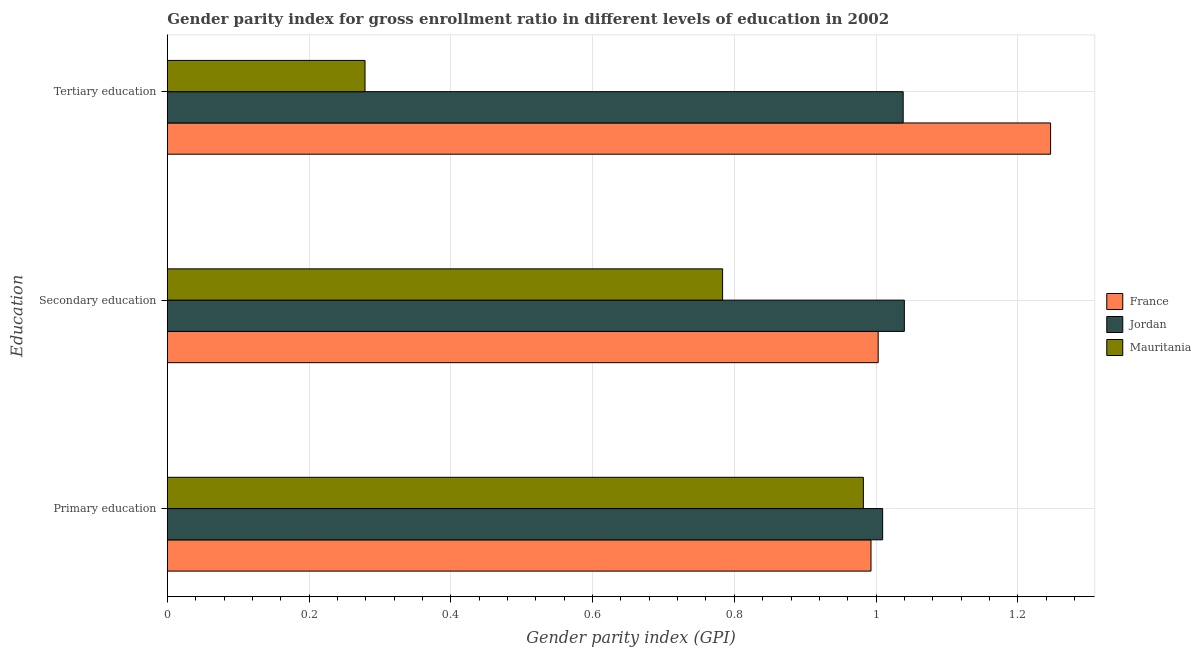How many different coloured bars are there?
Your answer should be very brief. 3. Are the number of bars per tick equal to the number of legend labels?
Your answer should be very brief. Yes. Are the number of bars on each tick of the Y-axis equal?
Provide a short and direct response. Yes. How many bars are there on the 2nd tick from the top?
Your answer should be very brief. 3. What is the gender parity index in tertiary education in Jordan?
Provide a succinct answer. 1.04. Across all countries, what is the maximum gender parity index in secondary education?
Your answer should be very brief. 1.04. Across all countries, what is the minimum gender parity index in secondary education?
Your answer should be very brief. 0.78. In which country was the gender parity index in secondary education maximum?
Your response must be concise. Jordan. In which country was the gender parity index in tertiary education minimum?
Make the answer very short. Mauritania. What is the total gender parity index in tertiary education in the graph?
Your response must be concise. 2.56. What is the difference between the gender parity index in primary education in France and that in Jordan?
Give a very brief answer. -0.02. What is the difference between the gender parity index in primary education in France and the gender parity index in secondary education in Mauritania?
Your response must be concise. 0.21. What is the average gender parity index in primary education per country?
Your answer should be very brief. 0.99. What is the difference between the gender parity index in tertiary education and gender parity index in secondary education in France?
Your answer should be compact. 0.24. In how many countries, is the gender parity index in tertiary education greater than 0.32 ?
Give a very brief answer. 2. What is the ratio of the gender parity index in secondary education in France to that in Mauritania?
Make the answer very short. 1.28. Is the difference between the gender parity index in primary education in France and Jordan greater than the difference between the gender parity index in tertiary education in France and Jordan?
Your response must be concise. No. What is the difference between the highest and the second highest gender parity index in tertiary education?
Your answer should be very brief. 0.21. What is the difference between the highest and the lowest gender parity index in tertiary education?
Your response must be concise. 0.97. Is the sum of the gender parity index in primary education in France and Jordan greater than the maximum gender parity index in tertiary education across all countries?
Provide a succinct answer. Yes. What does the 3rd bar from the bottom in Tertiary education represents?
Your response must be concise. Mauritania. Are all the bars in the graph horizontal?
Keep it short and to the point. Yes. What is the difference between two consecutive major ticks on the X-axis?
Provide a succinct answer. 0.2. How are the legend labels stacked?
Offer a very short reply. Vertical. What is the title of the graph?
Your answer should be compact. Gender parity index for gross enrollment ratio in different levels of education in 2002. Does "Sao Tome and Principe" appear as one of the legend labels in the graph?
Give a very brief answer. No. What is the label or title of the X-axis?
Give a very brief answer. Gender parity index (GPI). What is the label or title of the Y-axis?
Your response must be concise. Education. What is the Gender parity index (GPI) in France in Primary education?
Provide a succinct answer. 0.99. What is the Gender parity index (GPI) in Jordan in Primary education?
Your answer should be very brief. 1.01. What is the Gender parity index (GPI) of Mauritania in Primary education?
Your response must be concise. 0.98. What is the Gender parity index (GPI) in France in Secondary education?
Keep it short and to the point. 1. What is the Gender parity index (GPI) in Jordan in Secondary education?
Keep it short and to the point. 1.04. What is the Gender parity index (GPI) in Mauritania in Secondary education?
Keep it short and to the point. 0.78. What is the Gender parity index (GPI) in France in Tertiary education?
Make the answer very short. 1.25. What is the Gender parity index (GPI) of Jordan in Tertiary education?
Provide a short and direct response. 1.04. What is the Gender parity index (GPI) of Mauritania in Tertiary education?
Give a very brief answer. 0.28. Across all Education, what is the maximum Gender parity index (GPI) of France?
Provide a succinct answer. 1.25. Across all Education, what is the maximum Gender parity index (GPI) of Jordan?
Give a very brief answer. 1.04. Across all Education, what is the maximum Gender parity index (GPI) in Mauritania?
Give a very brief answer. 0.98. Across all Education, what is the minimum Gender parity index (GPI) of France?
Your answer should be compact. 0.99. Across all Education, what is the minimum Gender parity index (GPI) of Jordan?
Keep it short and to the point. 1.01. Across all Education, what is the minimum Gender parity index (GPI) of Mauritania?
Your answer should be compact. 0.28. What is the total Gender parity index (GPI) in France in the graph?
Your answer should be compact. 3.24. What is the total Gender parity index (GPI) of Jordan in the graph?
Provide a succinct answer. 3.09. What is the total Gender parity index (GPI) in Mauritania in the graph?
Your response must be concise. 2.04. What is the difference between the Gender parity index (GPI) in France in Primary education and that in Secondary education?
Your answer should be compact. -0.01. What is the difference between the Gender parity index (GPI) of Jordan in Primary education and that in Secondary education?
Offer a very short reply. -0.03. What is the difference between the Gender parity index (GPI) in Mauritania in Primary education and that in Secondary education?
Your answer should be very brief. 0.2. What is the difference between the Gender parity index (GPI) in France in Primary education and that in Tertiary education?
Offer a very short reply. -0.25. What is the difference between the Gender parity index (GPI) in Jordan in Primary education and that in Tertiary education?
Keep it short and to the point. -0.03. What is the difference between the Gender parity index (GPI) in Mauritania in Primary education and that in Tertiary education?
Your answer should be compact. 0.7. What is the difference between the Gender parity index (GPI) in France in Secondary education and that in Tertiary education?
Your answer should be very brief. -0.24. What is the difference between the Gender parity index (GPI) in Jordan in Secondary education and that in Tertiary education?
Ensure brevity in your answer.  0. What is the difference between the Gender parity index (GPI) of Mauritania in Secondary education and that in Tertiary education?
Offer a very short reply. 0.5. What is the difference between the Gender parity index (GPI) in France in Primary education and the Gender parity index (GPI) in Jordan in Secondary education?
Your answer should be very brief. -0.05. What is the difference between the Gender parity index (GPI) in France in Primary education and the Gender parity index (GPI) in Mauritania in Secondary education?
Make the answer very short. 0.21. What is the difference between the Gender parity index (GPI) of Jordan in Primary education and the Gender parity index (GPI) of Mauritania in Secondary education?
Your response must be concise. 0.23. What is the difference between the Gender parity index (GPI) in France in Primary education and the Gender parity index (GPI) in Jordan in Tertiary education?
Ensure brevity in your answer.  -0.05. What is the difference between the Gender parity index (GPI) of France in Primary education and the Gender parity index (GPI) of Mauritania in Tertiary education?
Your response must be concise. 0.71. What is the difference between the Gender parity index (GPI) in Jordan in Primary education and the Gender parity index (GPI) in Mauritania in Tertiary education?
Provide a succinct answer. 0.73. What is the difference between the Gender parity index (GPI) in France in Secondary education and the Gender parity index (GPI) in Jordan in Tertiary education?
Make the answer very short. -0.04. What is the difference between the Gender parity index (GPI) of France in Secondary education and the Gender parity index (GPI) of Mauritania in Tertiary education?
Ensure brevity in your answer.  0.72. What is the difference between the Gender parity index (GPI) in Jordan in Secondary education and the Gender parity index (GPI) in Mauritania in Tertiary education?
Keep it short and to the point. 0.76. What is the average Gender parity index (GPI) of France per Education?
Your answer should be very brief. 1.08. What is the average Gender parity index (GPI) of Jordan per Education?
Your response must be concise. 1.03. What is the average Gender parity index (GPI) in Mauritania per Education?
Your answer should be compact. 0.68. What is the difference between the Gender parity index (GPI) in France and Gender parity index (GPI) in Jordan in Primary education?
Provide a short and direct response. -0.02. What is the difference between the Gender parity index (GPI) in France and Gender parity index (GPI) in Mauritania in Primary education?
Give a very brief answer. 0.01. What is the difference between the Gender parity index (GPI) of Jordan and Gender parity index (GPI) of Mauritania in Primary education?
Make the answer very short. 0.03. What is the difference between the Gender parity index (GPI) in France and Gender parity index (GPI) in Jordan in Secondary education?
Your answer should be compact. -0.04. What is the difference between the Gender parity index (GPI) in France and Gender parity index (GPI) in Mauritania in Secondary education?
Your answer should be very brief. 0.22. What is the difference between the Gender parity index (GPI) of Jordan and Gender parity index (GPI) of Mauritania in Secondary education?
Provide a short and direct response. 0.26. What is the difference between the Gender parity index (GPI) in France and Gender parity index (GPI) in Jordan in Tertiary education?
Your response must be concise. 0.21. What is the difference between the Gender parity index (GPI) in France and Gender parity index (GPI) in Mauritania in Tertiary education?
Keep it short and to the point. 0.97. What is the difference between the Gender parity index (GPI) in Jordan and Gender parity index (GPI) in Mauritania in Tertiary education?
Ensure brevity in your answer.  0.76. What is the ratio of the Gender parity index (GPI) in Jordan in Primary education to that in Secondary education?
Ensure brevity in your answer.  0.97. What is the ratio of the Gender parity index (GPI) in Mauritania in Primary education to that in Secondary education?
Give a very brief answer. 1.25. What is the ratio of the Gender parity index (GPI) of France in Primary education to that in Tertiary education?
Offer a very short reply. 0.8. What is the ratio of the Gender parity index (GPI) in Jordan in Primary education to that in Tertiary education?
Offer a terse response. 0.97. What is the ratio of the Gender parity index (GPI) in Mauritania in Primary education to that in Tertiary education?
Provide a short and direct response. 3.52. What is the ratio of the Gender parity index (GPI) of France in Secondary education to that in Tertiary education?
Ensure brevity in your answer.  0.8. What is the ratio of the Gender parity index (GPI) in Jordan in Secondary education to that in Tertiary education?
Your answer should be compact. 1. What is the ratio of the Gender parity index (GPI) in Mauritania in Secondary education to that in Tertiary education?
Keep it short and to the point. 2.81. What is the difference between the highest and the second highest Gender parity index (GPI) of France?
Make the answer very short. 0.24. What is the difference between the highest and the second highest Gender parity index (GPI) of Jordan?
Your response must be concise. 0. What is the difference between the highest and the second highest Gender parity index (GPI) in Mauritania?
Keep it short and to the point. 0.2. What is the difference between the highest and the lowest Gender parity index (GPI) of France?
Make the answer very short. 0.25. What is the difference between the highest and the lowest Gender parity index (GPI) in Jordan?
Make the answer very short. 0.03. What is the difference between the highest and the lowest Gender parity index (GPI) of Mauritania?
Offer a terse response. 0.7. 